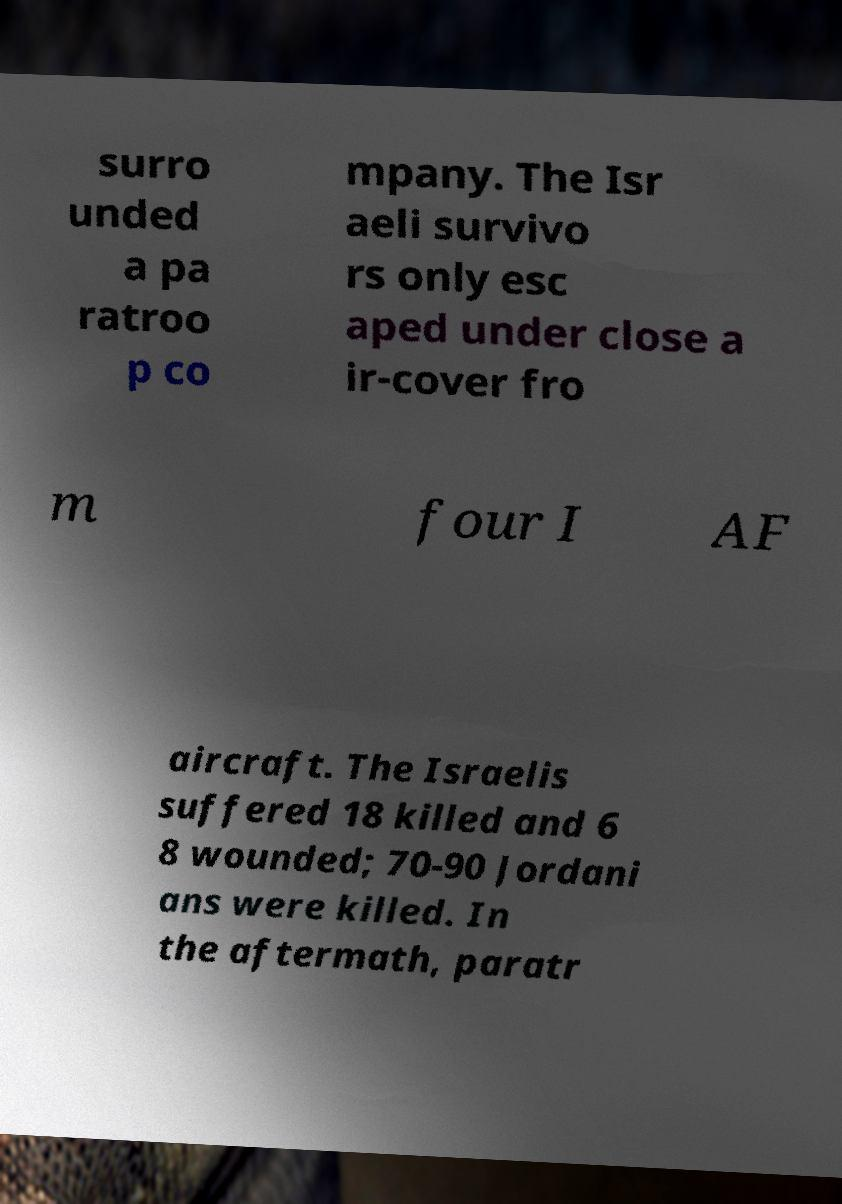Could you assist in decoding the text presented in this image and type it out clearly? surro unded a pa ratroo p co mpany. The Isr aeli survivo rs only esc aped under close a ir-cover fro m four I AF aircraft. The Israelis suffered 18 killed and 6 8 wounded; 70-90 Jordani ans were killed. In the aftermath, paratr 